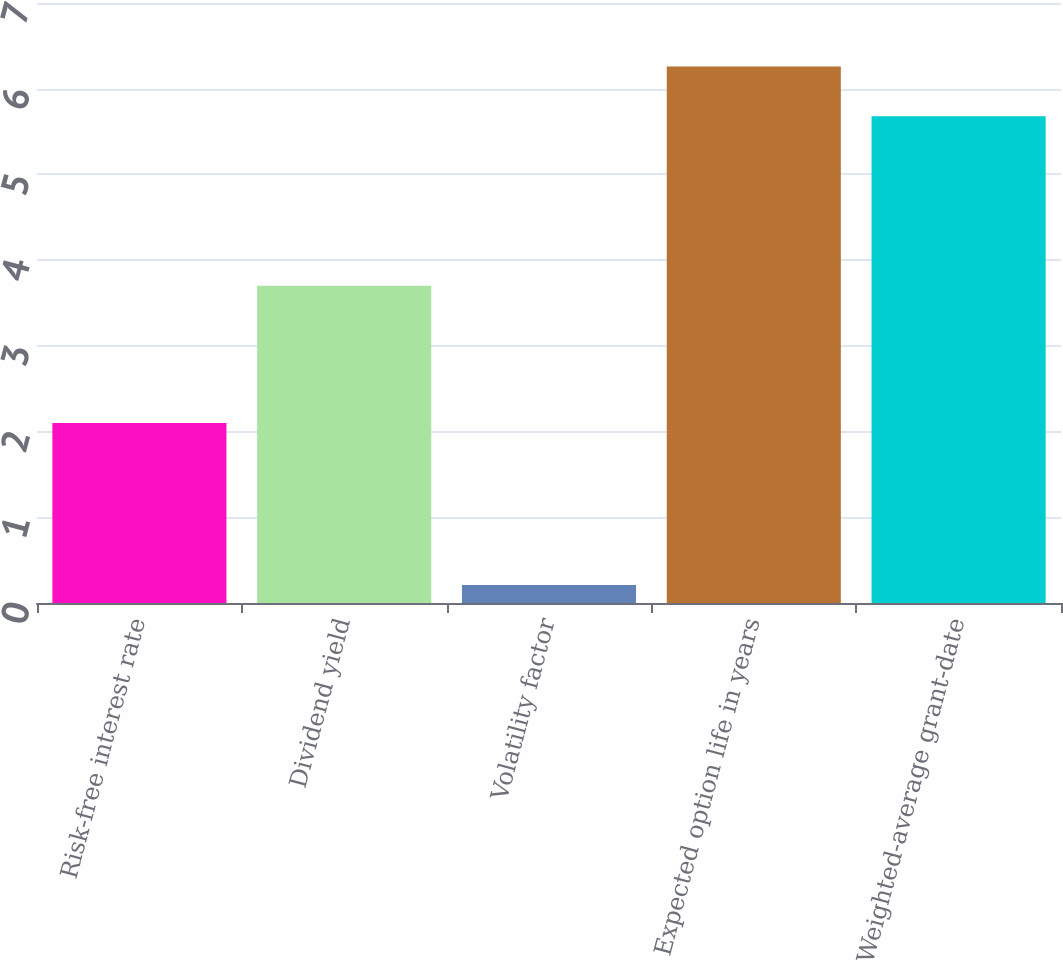Convert chart. <chart><loc_0><loc_0><loc_500><loc_500><bar_chart><fcel>Risk-free interest rate<fcel>Dividend yield<fcel>Volatility factor<fcel>Expected option life in years<fcel>Weighted-average grant-date<nl><fcel>2.1<fcel>3.7<fcel>0.21<fcel>6.26<fcel>5.68<nl></chart> 